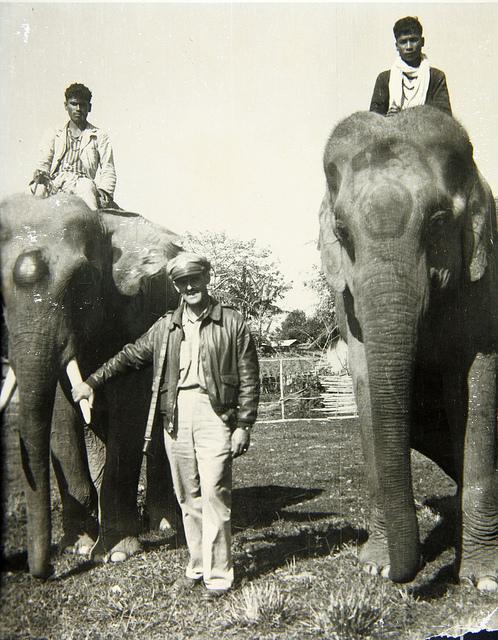How many elephants are there?
Give a very brief answer. 2. How many people are visible?
Give a very brief answer. 3. 